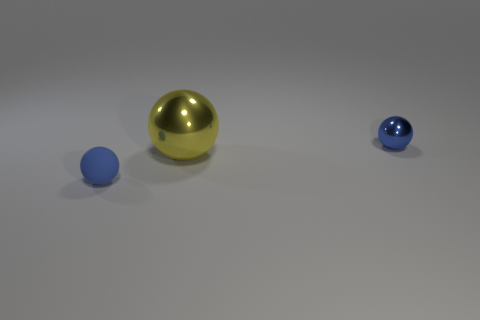Add 1 tiny blue shiny cylinders. How many objects exist? 4 Subtract all yellow balls. How many balls are left? 2 Subtract all big shiny spheres. How many spheres are left? 2 Subtract 2 spheres. How many spheres are left? 1 Subtract all brown cubes. How many blue spheres are left? 2 Subtract all cyan blocks. Subtract all tiny metallic balls. How many objects are left? 2 Add 3 yellow metallic balls. How many yellow metallic balls are left? 4 Add 3 yellow metal balls. How many yellow metal balls exist? 4 Subtract 2 blue spheres. How many objects are left? 1 Subtract all red spheres. Subtract all red cylinders. How many spheres are left? 3 